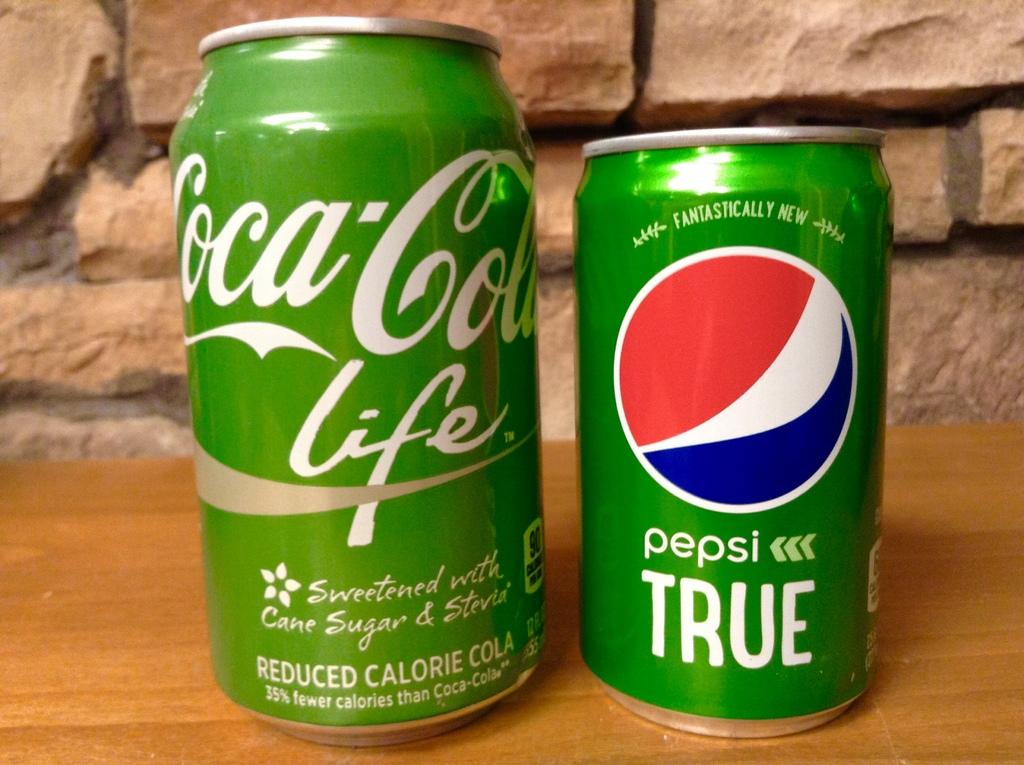<image>
Share a concise interpretation of the image provided. A green can of Pepsi sits next to a green can of Coke. 